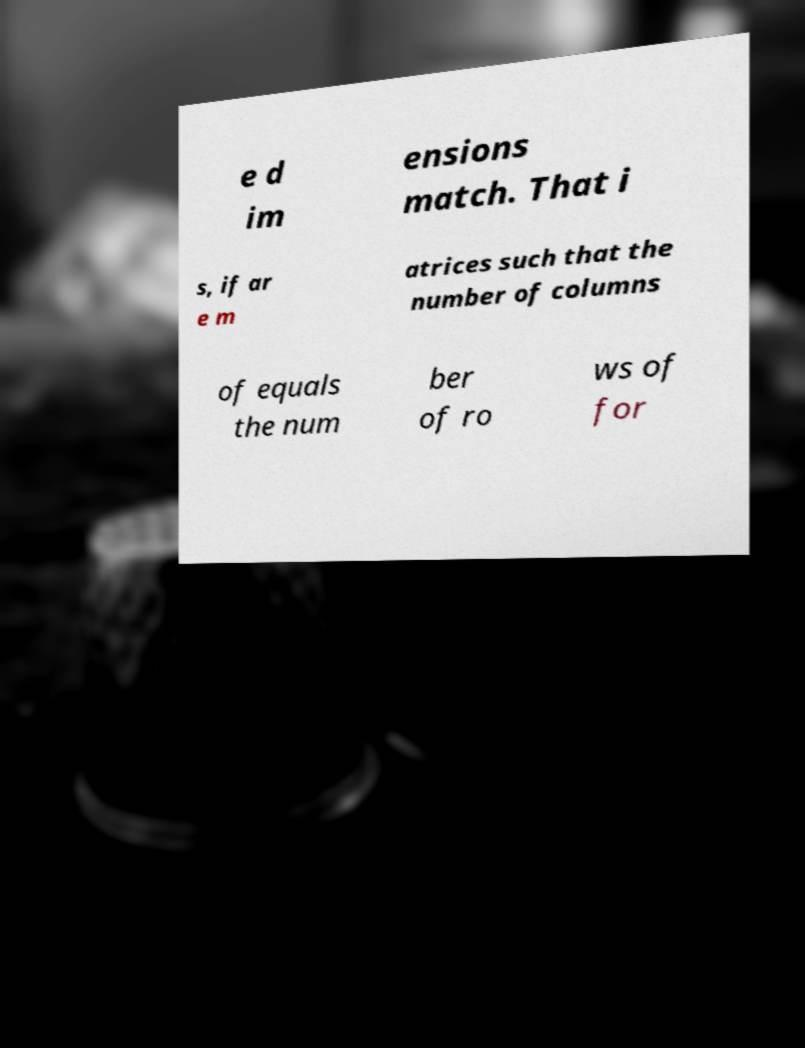There's text embedded in this image that I need extracted. Can you transcribe it verbatim? e d im ensions match. That i s, if ar e m atrices such that the number of columns of equals the num ber of ro ws of for 